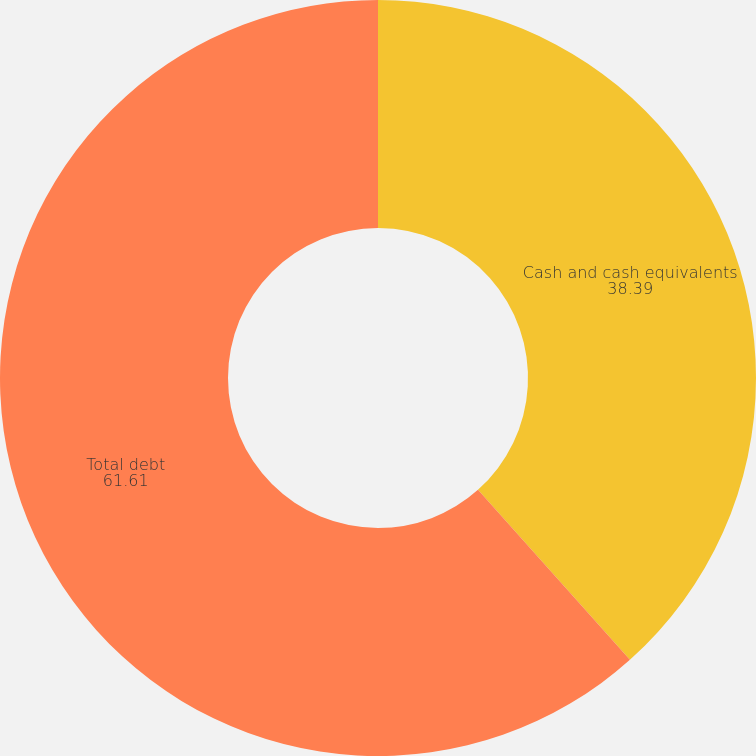<chart> <loc_0><loc_0><loc_500><loc_500><pie_chart><fcel>Cash and cash equivalents<fcel>Total debt<nl><fcel>38.39%<fcel>61.61%<nl></chart> 